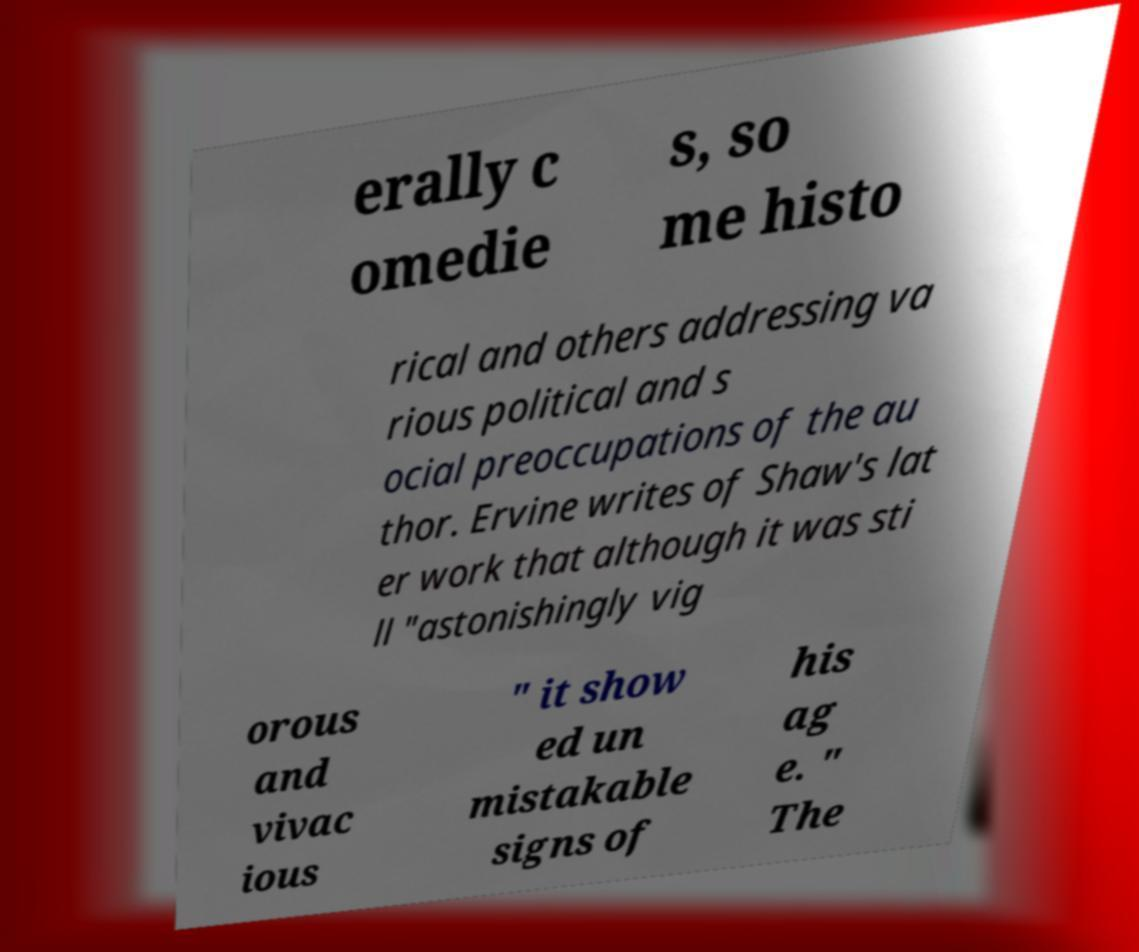I need the written content from this picture converted into text. Can you do that? erally c omedie s, so me histo rical and others addressing va rious political and s ocial preoccupations of the au thor. Ervine writes of Shaw's lat er work that although it was sti ll "astonishingly vig orous and vivac ious " it show ed un mistakable signs of his ag e. " The 